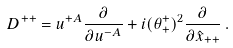<formula> <loc_0><loc_0><loc_500><loc_500>D ^ { + + } = u ^ { + A } { \frac { \partial } { \partial u ^ { - A } } } + i ( \theta _ { + } ^ { + } ) ^ { 2 } { \frac { \partial } { \partial \hat { x } _ { + + } } } \, .</formula> 